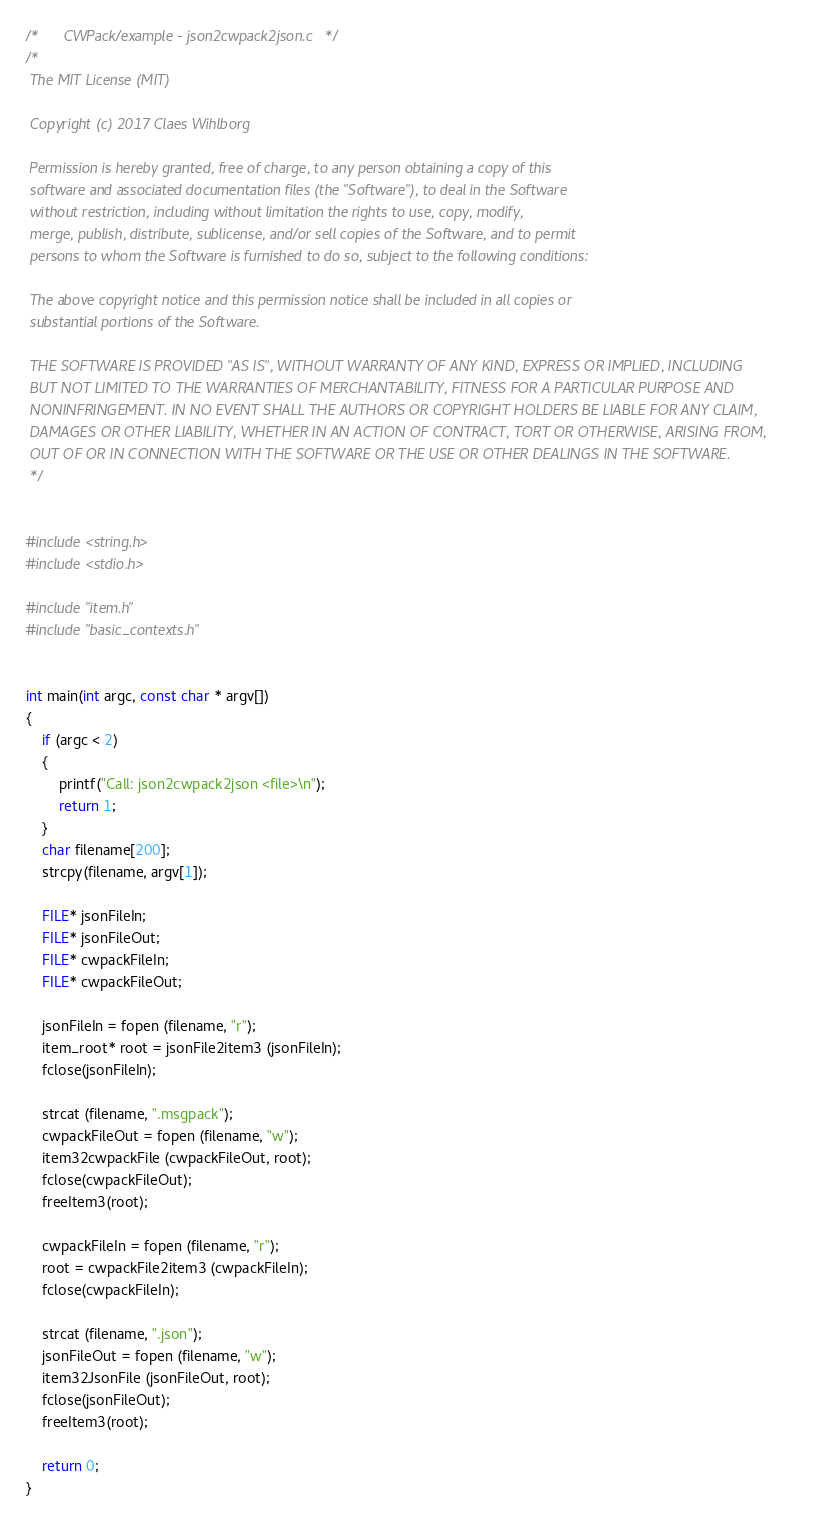Convert code to text. <code><loc_0><loc_0><loc_500><loc_500><_C_>/*      CWPack/example - json2cwpack2json.c   */
/*
 The MIT License (MIT)

 Copyright (c) 2017 Claes Wihlborg

 Permission is hereby granted, free of charge, to any person obtaining a copy of this
 software and associated documentation files (the "Software"), to deal in the Software
 without restriction, including without limitation the rights to use, copy, modify,
 merge, publish, distribute, sublicense, and/or sell copies of the Software, and to permit
 persons to whom the Software is furnished to do so, subject to the following conditions:

 The above copyright notice and this permission notice shall be included in all copies or
 substantial portions of the Software.

 THE SOFTWARE IS PROVIDED "AS IS", WITHOUT WARRANTY OF ANY KIND, EXPRESS OR IMPLIED, INCLUDING
 BUT NOT LIMITED TO THE WARRANTIES OF MERCHANTABILITY, FITNESS FOR A PARTICULAR PURPOSE AND
 NONINFRINGEMENT. IN NO EVENT SHALL THE AUTHORS OR COPYRIGHT HOLDERS BE LIABLE FOR ANY CLAIM,
 DAMAGES OR OTHER LIABILITY, WHETHER IN AN ACTION OF CONTRACT, TORT OR OTHERWISE, ARISING FROM,
 OUT OF OR IN CONNECTION WITH THE SOFTWARE OR THE USE OR OTHER DEALINGS IN THE SOFTWARE.
 */


#include <string.h>
#include <stdio.h>

#include "item.h"
#include "basic_contexts.h"


int main(int argc, const char * argv[])
{
    if (argc < 2)
    {
        printf("Call: json2cwpack2json <file>\n");
        return 1;
    }
    char filename[200];
    strcpy(filename, argv[1]);

    FILE* jsonFileIn;
    FILE* jsonFileOut;
    FILE* cwpackFileIn;
    FILE* cwpackFileOut;

    jsonFileIn = fopen (filename, "r");
    item_root* root = jsonFile2item3 (jsonFileIn);
    fclose(jsonFileIn);

    strcat (filename, ".msgpack");
    cwpackFileOut = fopen (filename, "w");
    item32cwpackFile (cwpackFileOut, root);
    fclose(cwpackFileOut);
    freeItem3(root);

    cwpackFileIn = fopen (filename, "r");
    root = cwpackFile2item3 (cwpackFileIn);
    fclose(cwpackFileIn);

    strcat (filename, ".json");
    jsonFileOut = fopen (filename, "w");
    item32JsonFile (jsonFileOut, root);
    fclose(jsonFileOut);
    freeItem3(root);

    return 0;
}
</code> 